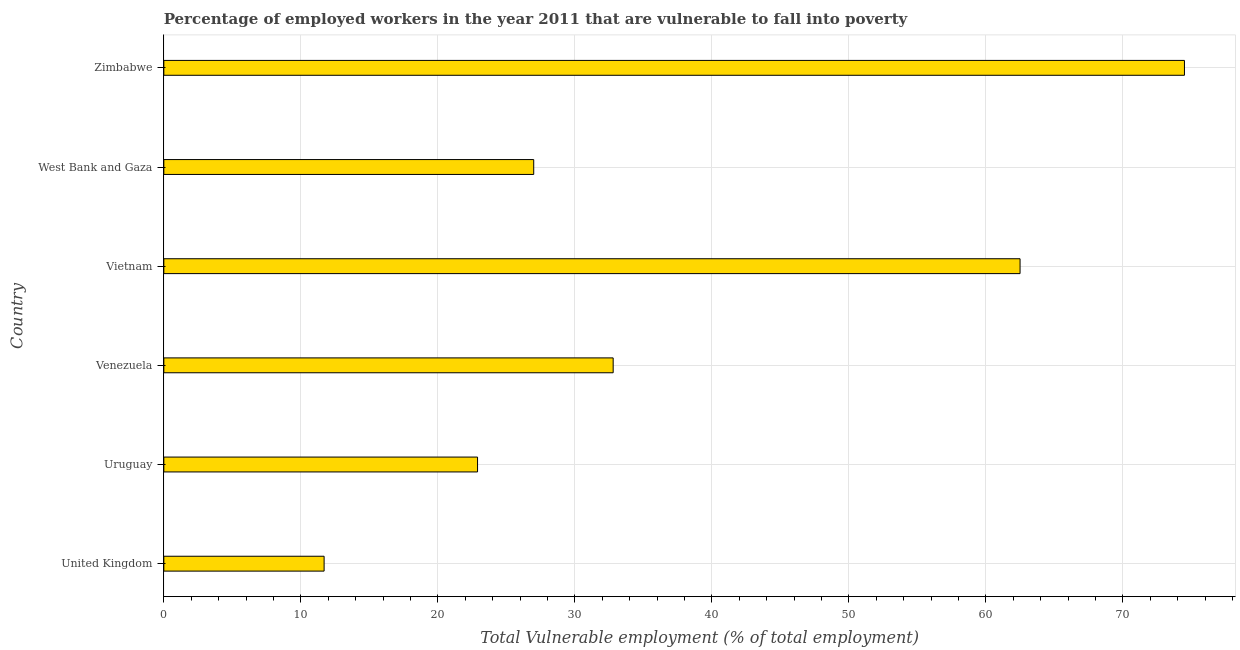Does the graph contain any zero values?
Your response must be concise. No. Does the graph contain grids?
Offer a very short reply. Yes. What is the title of the graph?
Give a very brief answer. Percentage of employed workers in the year 2011 that are vulnerable to fall into poverty. What is the label or title of the X-axis?
Offer a very short reply. Total Vulnerable employment (% of total employment). What is the total vulnerable employment in Zimbabwe?
Provide a short and direct response. 74.5. Across all countries, what is the maximum total vulnerable employment?
Keep it short and to the point. 74.5. Across all countries, what is the minimum total vulnerable employment?
Give a very brief answer. 11.7. In which country was the total vulnerable employment maximum?
Provide a short and direct response. Zimbabwe. What is the sum of the total vulnerable employment?
Ensure brevity in your answer.  231.4. What is the difference between the total vulnerable employment in Uruguay and West Bank and Gaza?
Your answer should be very brief. -4.1. What is the average total vulnerable employment per country?
Keep it short and to the point. 38.57. What is the median total vulnerable employment?
Keep it short and to the point. 29.9. What is the ratio of the total vulnerable employment in Uruguay to that in West Bank and Gaza?
Your response must be concise. 0.85. Is the total vulnerable employment in United Kingdom less than that in Uruguay?
Keep it short and to the point. Yes. What is the difference between the highest and the second highest total vulnerable employment?
Your response must be concise. 12. What is the difference between the highest and the lowest total vulnerable employment?
Your response must be concise. 62.8. In how many countries, is the total vulnerable employment greater than the average total vulnerable employment taken over all countries?
Offer a terse response. 2. What is the difference between two consecutive major ticks on the X-axis?
Keep it short and to the point. 10. Are the values on the major ticks of X-axis written in scientific E-notation?
Provide a succinct answer. No. What is the Total Vulnerable employment (% of total employment) of United Kingdom?
Provide a succinct answer. 11.7. What is the Total Vulnerable employment (% of total employment) in Uruguay?
Your response must be concise. 22.9. What is the Total Vulnerable employment (% of total employment) in Venezuela?
Offer a terse response. 32.8. What is the Total Vulnerable employment (% of total employment) in Vietnam?
Your answer should be very brief. 62.5. What is the Total Vulnerable employment (% of total employment) in Zimbabwe?
Give a very brief answer. 74.5. What is the difference between the Total Vulnerable employment (% of total employment) in United Kingdom and Venezuela?
Your answer should be very brief. -21.1. What is the difference between the Total Vulnerable employment (% of total employment) in United Kingdom and Vietnam?
Offer a very short reply. -50.8. What is the difference between the Total Vulnerable employment (% of total employment) in United Kingdom and West Bank and Gaza?
Your answer should be very brief. -15.3. What is the difference between the Total Vulnerable employment (% of total employment) in United Kingdom and Zimbabwe?
Provide a succinct answer. -62.8. What is the difference between the Total Vulnerable employment (% of total employment) in Uruguay and Vietnam?
Provide a short and direct response. -39.6. What is the difference between the Total Vulnerable employment (% of total employment) in Uruguay and Zimbabwe?
Ensure brevity in your answer.  -51.6. What is the difference between the Total Vulnerable employment (% of total employment) in Venezuela and Vietnam?
Keep it short and to the point. -29.7. What is the difference between the Total Vulnerable employment (% of total employment) in Venezuela and West Bank and Gaza?
Make the answer very short. 5.8. What is the difference between the Total Vulnerable employment (% of total employment) in Venezuela and Zimbabwe?
Offer a terse response. -41.7. What is the difference between the Total Vulnerable employment (% of total employment) in Vietnam and West Bank and Gaza?
Make the answer very short. 35.5. What is the difference between the Total Vulnerable employment (% of total employment) in West Bank and Gaza and Zimbabwe?
Offer a terse response. -47.5. What is the ratio of the Total Vulnerable employment (% of total employment) in United Kingdom to that in Uruguay?
Provide a succinct answer. 0.51. What is the ratio of the Total Vulnerable employment (% of total employment) in United Kingdom to that in Venezuela?
Ensure brevity in your answer.  0.36. What is the ratio of the Total Vulnerable employment (% of total employment) in United Kingdom to that in Vietnam?
Your answer should be compact. 0.19. What is the ratio of the Total Vulnerable employment (% of total employment) in United Kingdom to that in West Bank and Gaza?
Offer a very short reply. 0.43. What is the ratio of the Total Vulnerable employment (% of total employment) in United Kingdom to that in Zimbabwe?
Provide a short and direct response. 0.16. What is the ratio of the Total Vulnerable employment (% of total employment) in Uruguay to that in Venezuela?
Give a very brief answer. 0.7. What is the ratio of the Total Vulnerable employment (% of total employment) in Uruguay to that in Vietnam?
Offer a terse response. 0.37. What is the ratio of the Total Vulnerable employment (% of total employment) in Uruguay to that in West Bank and Gaza?
Offer a very short reply. 0.85. What is the ratio of the Total Vulnerable employment (% of total employment) in Uruguay to that in Zimbabwe?
Ensure brevity in your answer.  0.31. What is the ratio of the Total Vulnerable employment (% of total employment) in Venezuela to that in Vietnam?
Offer a terse response. 0.53. What is the ratio of the Total Vulnerable employment (% of total employment) in Venezuela to that in West Bank and Gaza?
Offer a very short reply. 1.22. What is the ratio of the Total Vulnerable employment (% of total employment) in Venezuela to that in Zimbabwe?
Make the answer very short. 0.44. What is the ratio of the Total Vulnerable employment (% of total employment) in Vietnam to that in West Bank and Gaza?
Your response must be concise. 2.31. What is the ratio of the Total Vulnerable employment (% of total employment) in Vietnam to that in Zimbabwe?
Make the answer very short. 0.84. What is the ratio of the Total Vulnerable employment (% of total employment) in West Bank and Gaza to that in Zimbabwe?
Your answer should be very brief. 0.36. 